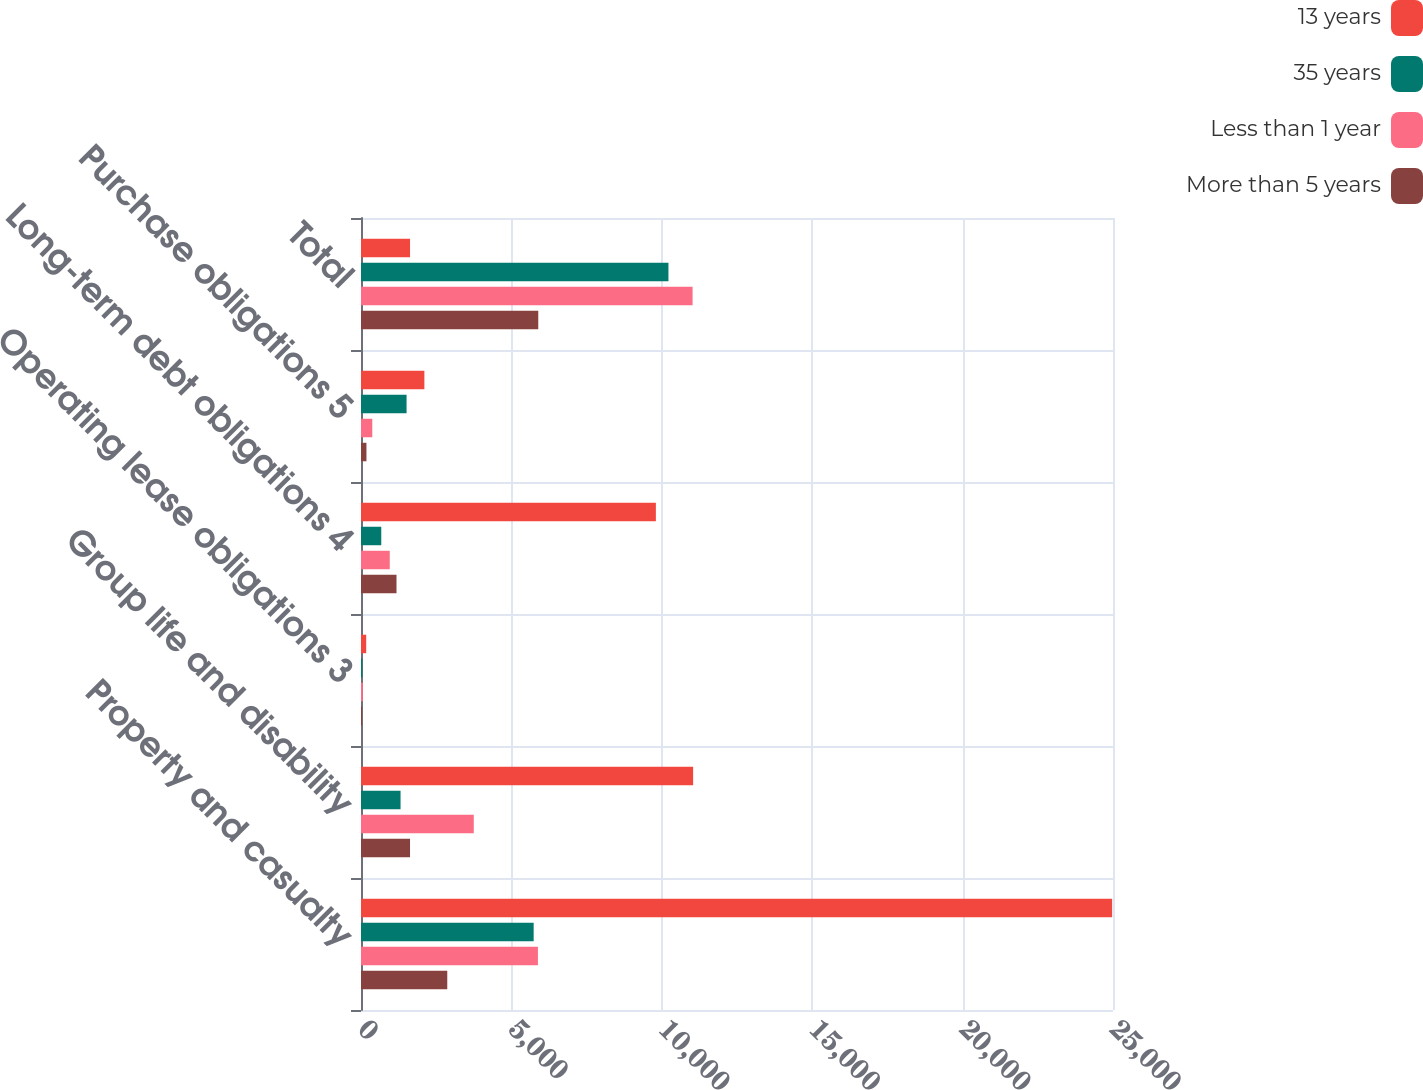<chart> <loc_0><loc_0><loc_500><loc_500><stacked_bar_chart><ecel><fcel>Property and casualty<fcel>Group life and disability<fcel>Operating lease obligations 3<fcel>Long-term debt obligations 4<fcel>Purchase obligations 5<fcel>Total<nl><fcel>13 years<fcel>24972<fcel>11041<fcel>173<fcel>9803<fcel>2107<fcel>1630<nl><fcel>35 years<fcel>5740<fcel>1315<fcel>44<fcel>674<fcel>1515<fcel>10221<nl><fcel>Less than 1 year<fcel>5882<fcel>3749<fcel>61<fcel>956<fcel>375<fcel>11023<nl><fcel>More than 5 years<fcel>2868<fcel>1630<fcel>34<fcel>1180<fcel>181<fcel>5893<nl></chart> 